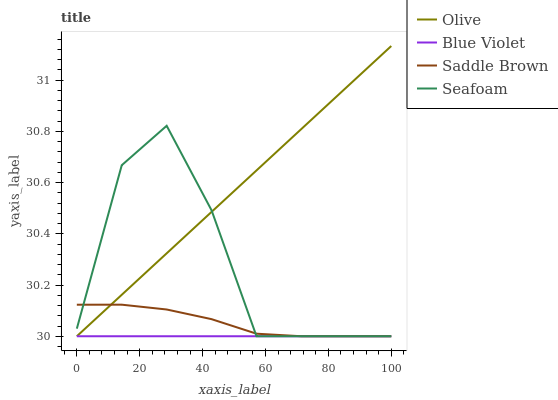Does Blue Violet have the minimum area under the curve?
Answer yes or no. Yes. Does Olive have the maximum area under the curve?
Answer yes or no. Yes. Does Saddle Brown have the minimum area under the curve?
Answer yes or no. No. Does Saddle Brown have the maximum area under the curve?
Answer yes or no. No. Is Blue Violet the smoothest?
Answer yes or no. Yes. Is Seafoam the roughest?
Answer yes or no. Yes. Is Saddle Brown the smoothest?
Answer yes or no. No. Is Saddle Brown the roughest?
Answer yes or no. No. Does Olive have the highest value?
Answer yes or no. Yes. Does Saddle Brown have the highest value?
Answer yes or no. No. 